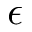Convert formula to latex. <formula><loc_0><loc_0><loc_500><loc_500>\epsilon</formula> 